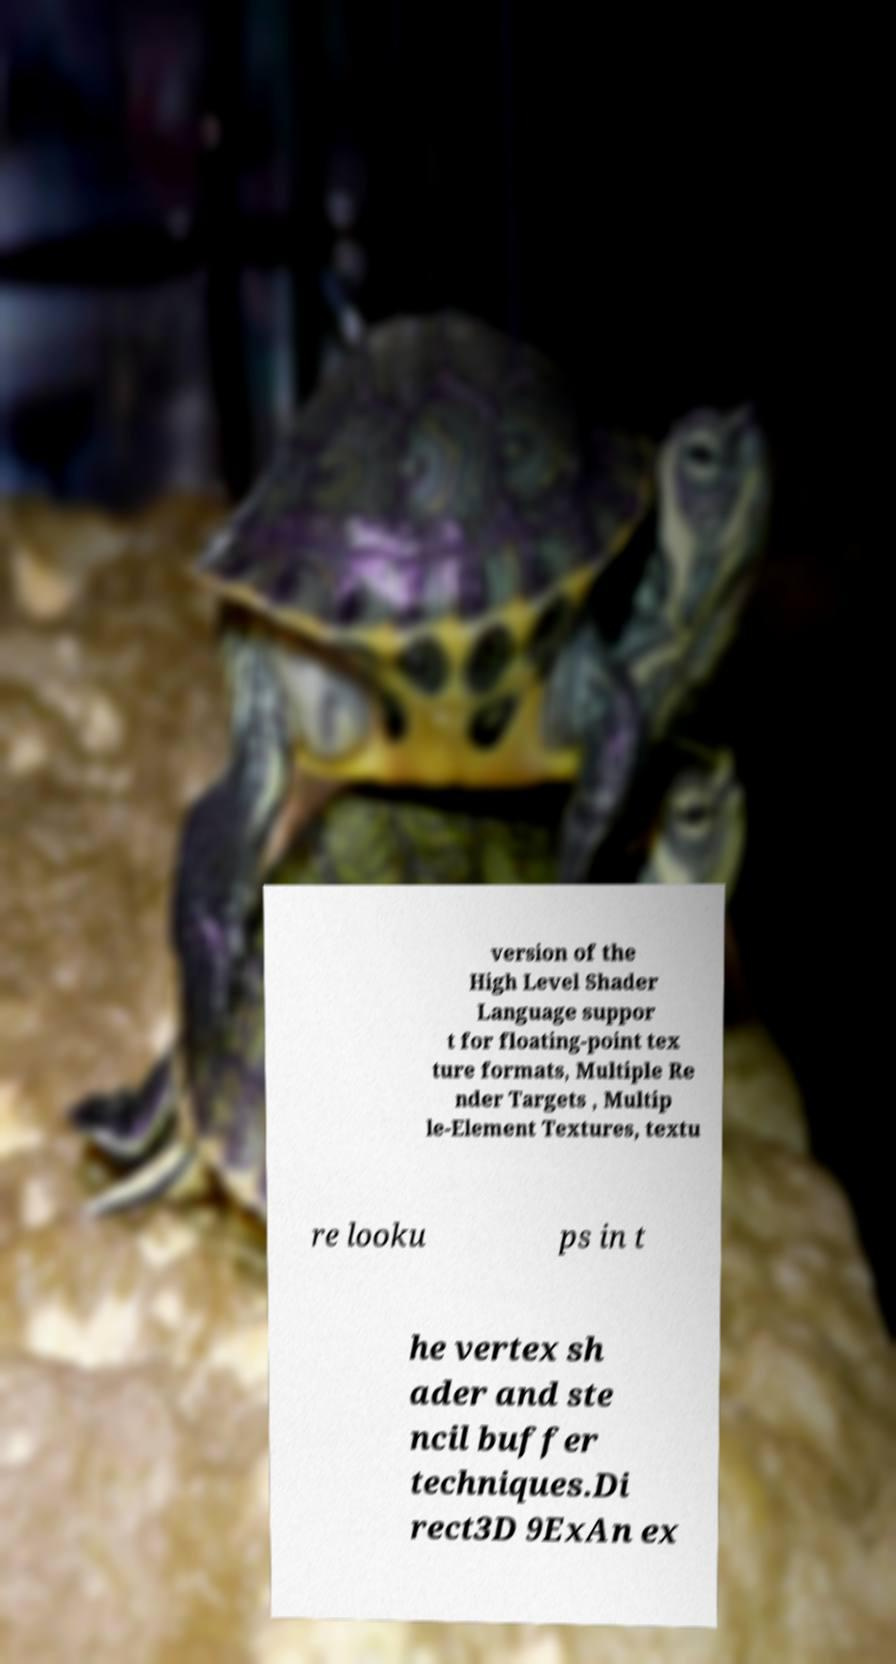Could you assist in decoding the text presented in this image and type it out clearly? version of the High Level Shader Language suppor t for floating-point tex ture formats, Multiple Re nder Targets , Multip le-Element Textures, textu re looku ps in t he vertex sh ader and ste ncil buffer techniques.Di rect3D 9ExAn ex 